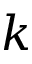<formula> <loc_0><loc_0><loc_500><loc_500>k</formula> 